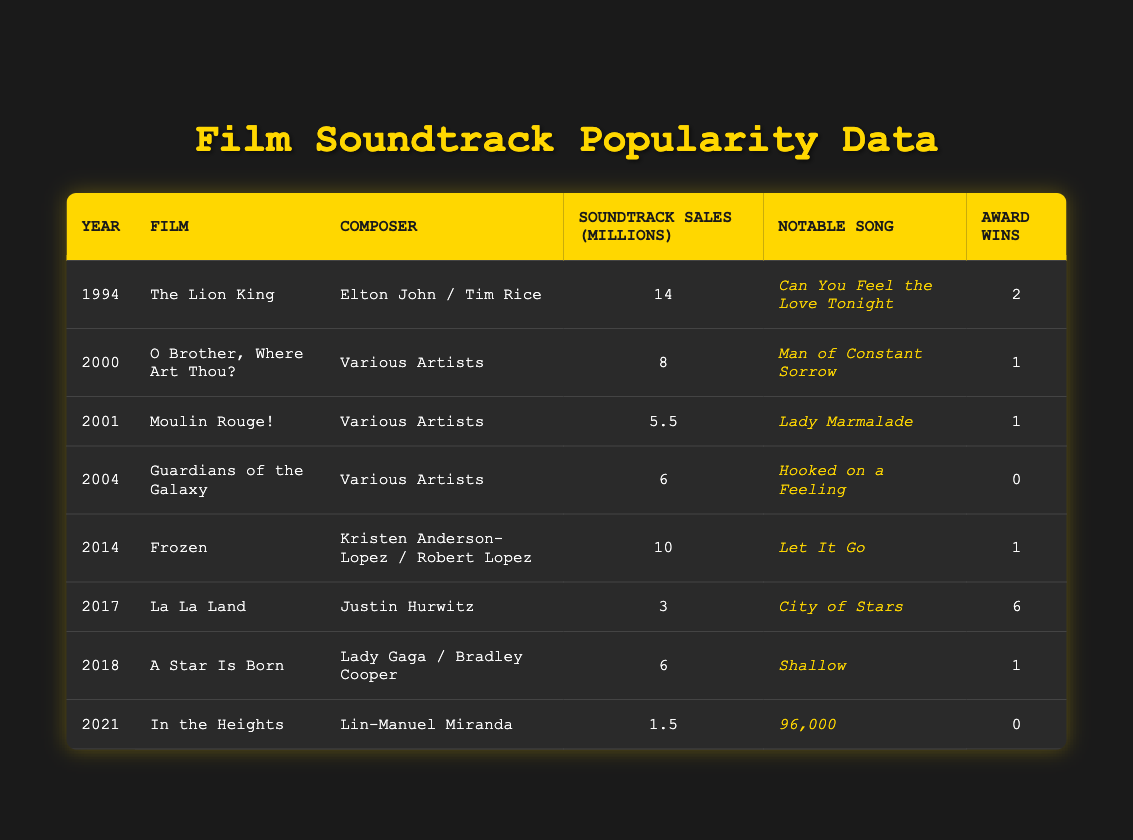What year was "The Lion King" released? The year in the table for "The Lion King" is listed as 1994.
Answer: 1994 Which film had the highest soundtrack sales? Looking at the "Soundtrack Sales (Millions)" column, "The Lion King" has the highest value at 14 million.
Answer: 14 million How many award wins did "La La Land" have? The table states that "La La Land" had 6 award wins listed in the "Award Wins" column.
Answer: 6 What notable song is associated with the "Frozen" soundtrack? The notable song for "Frozen" listed in the table is "Let It Go."
Answer: Let It Go Which film's soundtrack sold less than 5 million copies? By checking the "Soundtrack Sales (Millions)" column, only "Moulin Rouge!" with 5.5 million and "In the Heights" with 1.5 million are below 5 million, but only "In the Heights" is under 5 million.
Answer: In the Heights What is the average number of award wins for the films in the table? To find the average, sum the award wins: (2 + 1 + 1 + 0 + 1 + 6 + 1 + 0) = 12. There are 8 films, so the average is 12/8 = 1.5.
Answer: 1.5 Did any film's soundtrack win more than 5 awards? Yes, "La La Land" is the only film in the table with more than 5 award wins, which is 6.
Answer: Yes Which film's notable song was written by Lin-Manuel Miranda? The film associated with Lin-Manuel Miranda listed in the table is "In the Heights," and its notable song is "96,000."
Answer: In the Heights How many films were released before 2010? Looking at the years, there are four films: "The Lion King" (1994), "O Brother, Where Art Thou?" (2000), "Moulin Rouge!" (2001), and "Guardians of the Galaxy" (2004).
Answer: 4 Is "Guardians of the Galaxy" the only film without award wins? Yes, according to the "Award Wins" column, "Guardians of the Galaxy" has 0 award wins while all others have at least 1.
Answer: Yes What was the total soundtrack sales of films released after 2010? The films released after 2010 are "La La Land" (3 million), "A Star Is Born" (6 million), and "In the Heights" (1.5 million); the total sales are 3 + 6 + 1.5 = 10.5 million.
Answer: 10.5 million Was "A Star Is Born" published in the same year as "Frozen"? No, "Frozen" was released in 2014 while "A Star Is Born" was released in 2018, which are different years.
Answer: No 